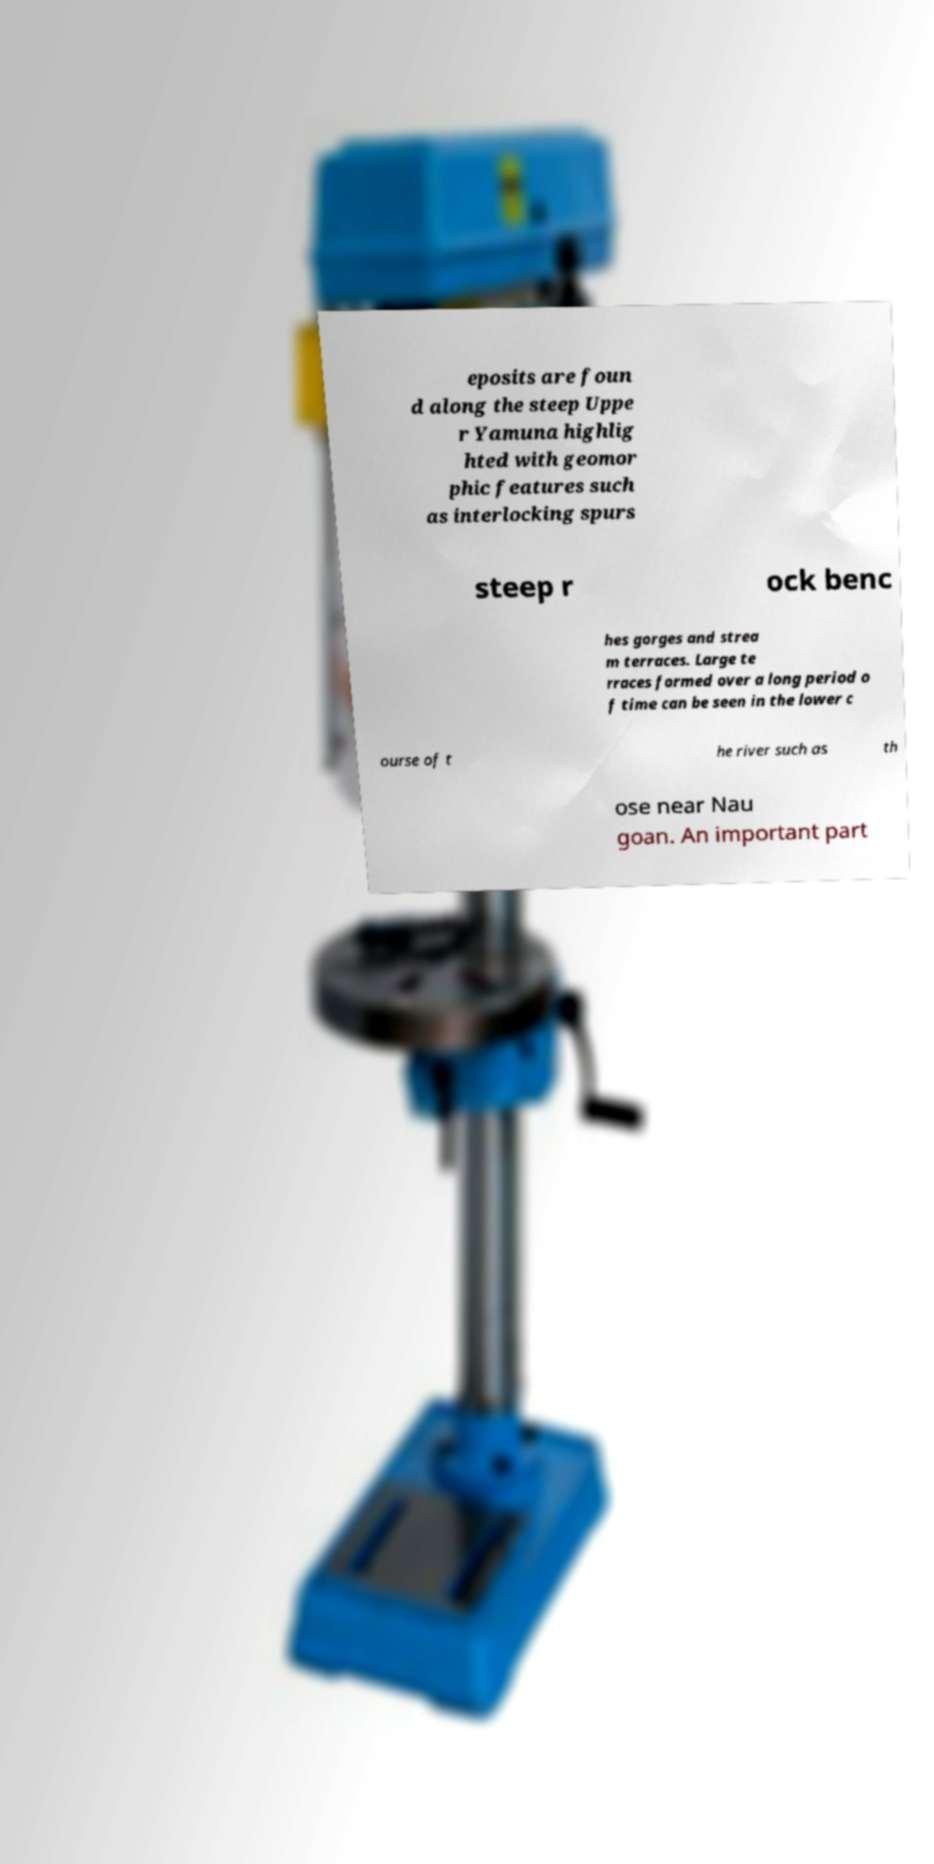What messages or text are displayed in this image? I need them in a readable, typed format. eposits are foun d along the steep Uppe r Yamuna highlig hted with geomor phic features such as interlocking spurs steep r ock benc hes gorges and strea m terraces. Large te rraces formed over a long period o f time can be seen in the lower c ourse of t he river such as th ose near Nau goan. An important part 